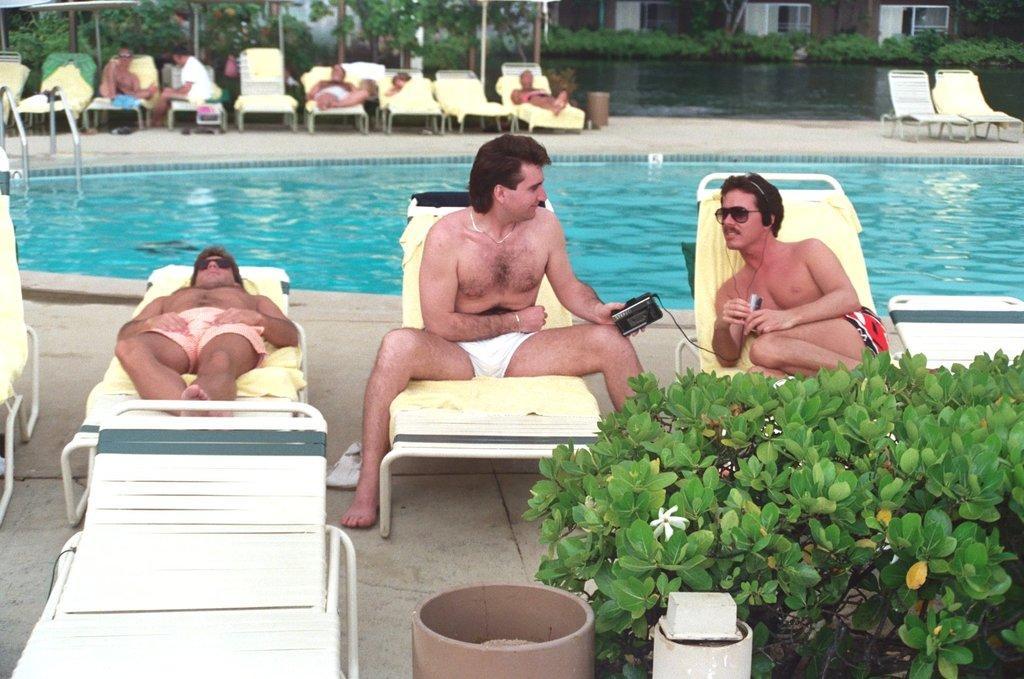Can you describe this image briefly? In this picture we can see water, beside the water we can see people on chairs on the ground, here we can see plants, flower, metal poles and some objects. 